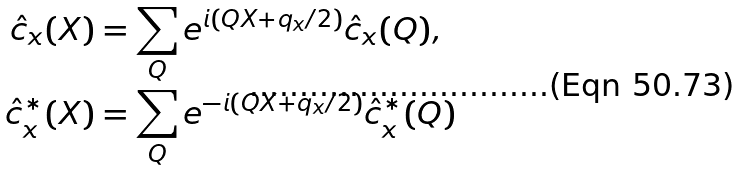<formula> <loc_0><loc_0><loc_500><loc_500>\hat { c } _ { x } ( X ) & = \sum _ { Q } e ^ { i ( Q X + q _ { x } / 2 ) } \hat { c } _ { x } ( Q ) , \\ \hat { c } ^ { * } _ { x } ( X ) & = \sum _ { Q } e ^ { - i ( Q X + q _ { x } / 2 ) } \hat { c } ^ { * } _ { x } ( Q )</formula> 